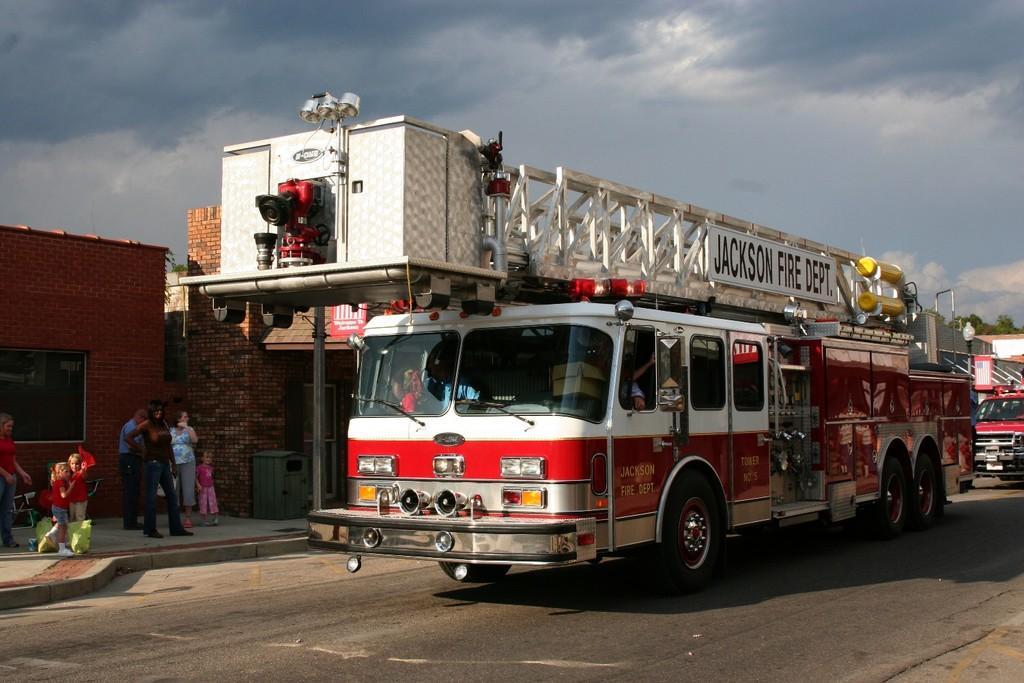Describe this image in one or two sentences. In this image I can see the vehicles on the road. To the side of the vehicles I can see the roof of the bus stop, few people with different color dresses and houses. I can see the boards to the roof. In the background I can see the clouds and the blue sky. 